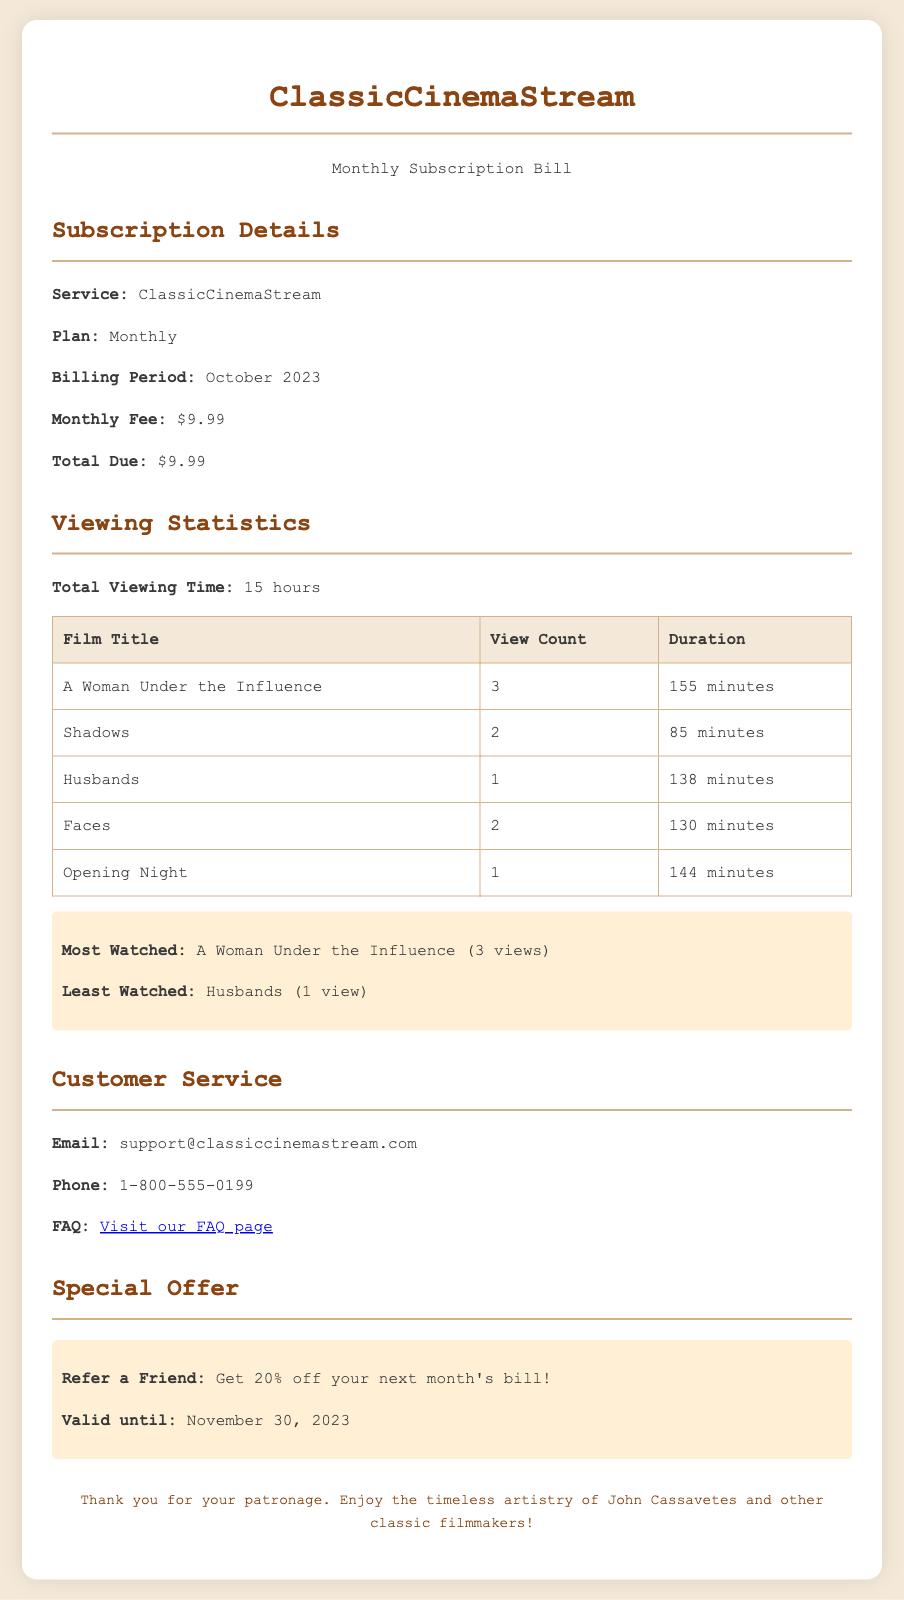What is the monthly fee? The monthly fee is specified in the subscription details.
Answer: $9.99 What is the billing period? The billing period is mentioned in the subscription details section.
Answer: October 2023 How many hours did I watch in total? The total viewing time is listed under viewing statistics.
Answer: 15 hours Which film was watched the most? This information is highlighted in the viewing statistics section.
Answer: A Woman Under the Influence How many views did "Husbands" receive? This view count is detailed in the table of viewing statistics.
Answer: 1 What is the special offer? The special offer is highlighted in the special offer section of the document.
Answer: Refer a Friend: Get 20% off your next month's bill! What is the email for customer service? The customer service email is provided in the customer service section.
Answer: support@classiccinemastream.com What is the total due amount? The total due is specified in the subscription details.
Answer: $9.99 How many films are listed in the viewing statistics? The number of films can be counted from the table provided.
Answer: 5 